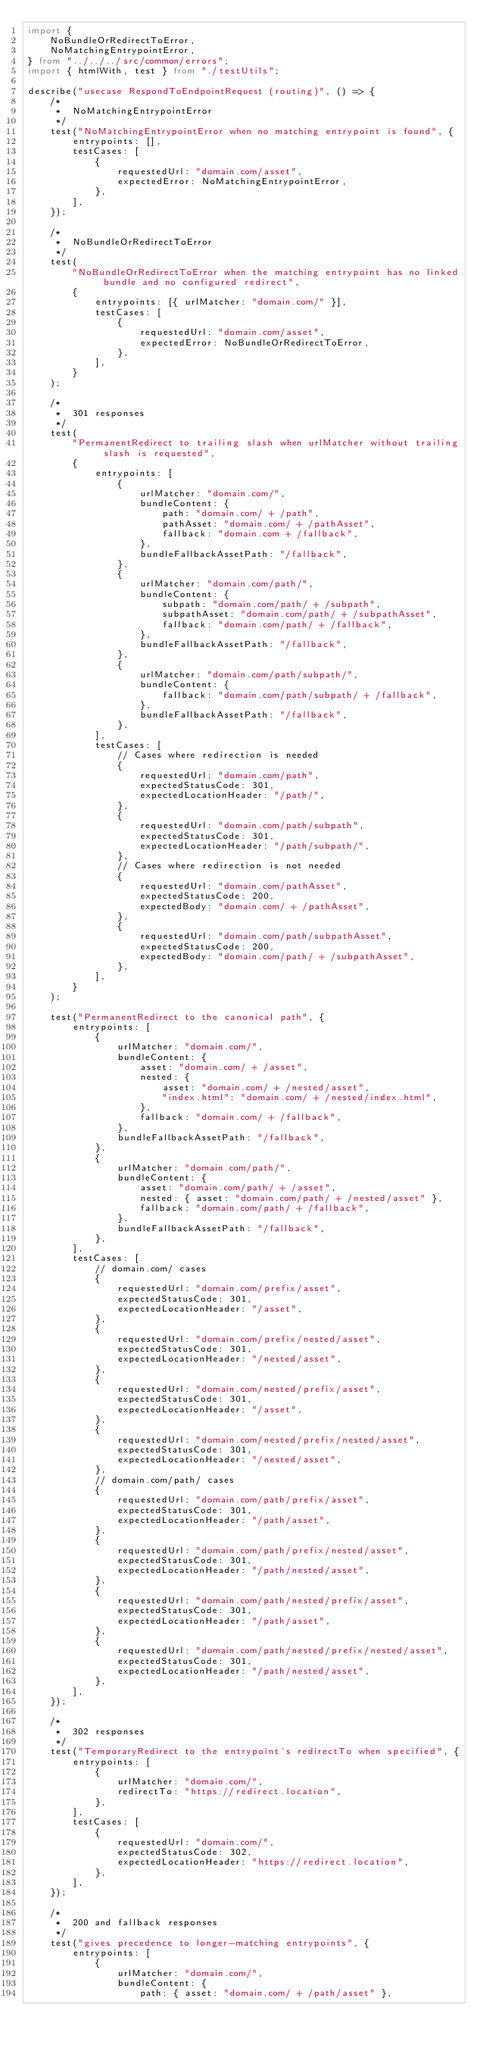Convert code to text. <code><loc_0><loc_0><loc_500><loc_500><_TypeScript_>import {
    NoBundleOrRedirectToError,
    NoMatchingEntrypointError,
} from "../../../src/common/errors";
import { htmlWith, test } from "./testUtils";

describe("usecase RespondToEndpointRequest (routing)", () => {
    /*
     *  NoMatchingEntrypointError
     */
    test("NoMatchingEntrypointError when no matching entrypoint is found", {
        entrypoints: [],
        testCases: [
            {
                requestedUrl: "domain.com/asset",
                expectedError: NoMatchingEntrypointError,
            },
        ],
    });

    /*
     *  NoBundleOrRedirectToError
     */
    test(
        "NoBundleOrRedirectToError when the matching entrypoint has no linked bundle and no configured redirect",
        {
            entrypoints: [{ urlMatcher: "domain.com/" }],
            testCases: [
                {
                    requestedUrl: "domain.com/asset",
                    expectedError: NoBundleOrRedirectToError,
                },
            ],
        }
    );

    /*
     *  301 responses
     */
    test(
        "PermanentRedirect to trailing slash when urlMatcher without trailing slash is requested",
        {
            entrypoints: [
                {
                    urlMatcher: "domain.com/",
                    bundleContent: {
                        path: "domain.com/ + /path",
                        pathAsset: "domain.com/ + /pathAsset",
                        fallback: "domain.com + /fallback",
                    },
                    bundleFallbackAssetPath: "/fallback",
                },
                {
                    urlMatcher: "domain.com/path/",
                    bundleContent: {
                        subpath: "domain.com/path/ + /subpath",
                        subpathAsset: "domain.com/path/ + /subpathAsset",
                        fallback: "domain.com/path/ + /fallback",
                    },
                    bundleFallbackAssetPath: "/fallback",
                },
                {
                    urlMatcher: "domain.com/path/subpath/",
                    bundleContent: {
                        fallback: "domain.com/path/subpath/ + /fallback",
                    },
                    bundleFallbackAssetPath: "/fallback",
                },
            ],
            testCases: [
                // Cases where redirection is needed
                {
                    requestedUrl: "domain.com/path",
                    expectedStatusCode: 301,
                    expectedLocationHeader: "/path/",
                },
                {
                    requestedUrl: "domain.com/path/subpath",
                    expectedStatusCode: 301,
                    expectedLocationHeader: "/path/subpath/",
                },
                // Cases where redirection is not needed
                {
                    requestedUrl: "domain.com/pathAsset",
                    expectedStatusCode: 200,
                    expectedBody: "domain.com/ + /pathAsset",
                },
                {
                    requestedUrl: "domain.com/path/subpathAsset",
                    expectedStatusCode: 200,
                    expectedBody: "domain.com/path/ + /subpathAsset",
                },
            ],
        }
    );

    test("PermanentRedirect to the canonical path", {
        entrypoints: [
            {
                urlMatcher: "domain.com/",
                bundleContent: {
                    asset: "domain.com/ + /asset",
                    nested: {
                        asset: "domain.com/ + /nested/asset",
                        "index.html": "domain.com/ + /nested/index.html",
                    },
                    fallback: "domain.com/ + /fallback",
                },
                bundleFallbackAssetPath: "/fallback",
            },
            {
                urlMatcher: "domain.com/path/",
                bundleContent: {
                    asset: "domain.com/path/ + /asset",
                    nested: { asset: "domain.com/path/ + /nested/asset" },
                    fallback: "domain.com/path/ + /fallback",
                },
                bundleFallbackAssetPath: "/fallback",
            },
        ],
        testCases: [
            // domain.com/ cases
            {
                requestedUrl: "domain.com/prefix/asset",
                expectedStatusCode: 301,
                expectedLocationHeader: "/asset",
            },
            {
                requestedUrl: "domain.com/prefix/nested/asset",
                expectedStatusCode: 301,
                expectedLocationHeader: "/nested/asset",
            },
            {
                requestedUrl: "domain.com/nested/prefix/asset",
                expectedStatusCode: 301,
                expectedLocationHeader: "/asset",
            },
            {
                requestedUrl: "domain.com/nested/prefix/nested/asset",
                expectedStatusCode: 301,
                expectedLocationHeader: "/nested/asset",
            },
            // domain.com/path/ cases
            {
                requestedUrl: "domain.com/path/prefix/asset",
                expectedStatusCode: 301,
                expectedLocationHeader: "/path/asset",
            },
            {
                requestedUrl: "domain.com/path/prefix/nested/asset",
                expectedStatusCode: 301,
                expectedLocationHeader: "/path/nested/asset",
            },
            {
                requestedUrl: "domain.com/path/nested/prefix/asset",
                expectedStatusCode: 301,
                expectedLocationHeader: "/path/asset",
            },
            {
                requestedUrl: "domain.com/path/nested/prefix/nested/asset",
                expectedStatusCode: 301,
                expectedLocationHeader: "/path/nested/asset",
            },
        ],
    });

    /*
     *  302 responses
     */
    test("TemporaryRedirect to the entrypoint's redirectTo when specified", {
        entrypoints: [
            {
                urlMatcher: "domain.com/",
                redirectTo: "https://redirect.location",
            },
        ],
        testCases: [
            {
                requestedUrl: "domain.com/",
                expectedStatusCode: 302,
                expectedLocationHeader: "https://redirect.location",
            },
        ],
    });

    /*
     *  200 and fallback responses
     */
    test("gives precedence to longer-matching entrypoints", {
        entrypoints: [
            {
                urlMatcher: "domain.com/",
                bundleContent: {
                    path: { asset: "domain.com/ + /path/asset" },</code> 